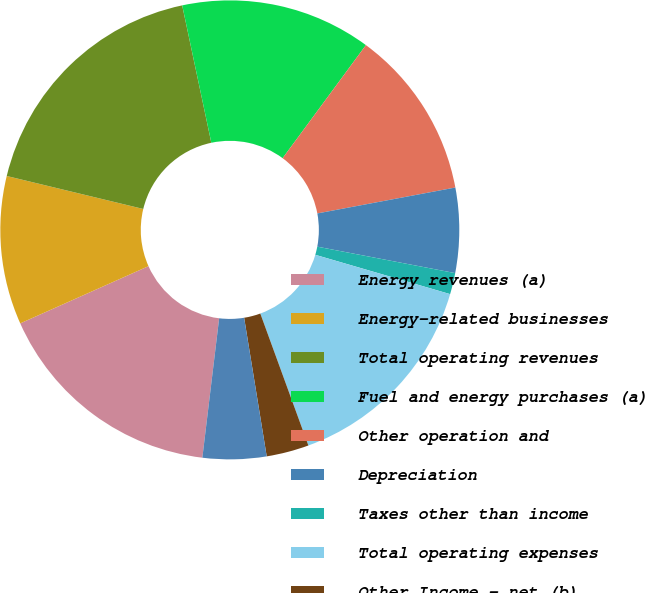<chart> <loc_0><loc_0><loc_500><loc_500><pie_chart><fcel>Energy revenues (a)<fcel>Energy-related businesses<fcel>Total operating revenues<fcel>Fuel and energy purchases (a)<fcel>Other operation and<fcel>Depreciation<fcel>Taxes other than income<fcel>Total operating expenses<fcel>Other Income - net (b)<fcel>Interest Expense (c)<nl><fcel>16.41%<fcel>10.45%<fcel>17.9%<fcel>13.43%<fcel>11.94%<fcel>5.97%<fcel>1.5%<fcel>14.92%<fcel>2.99%<fcel>4.48%<nl></chart> 